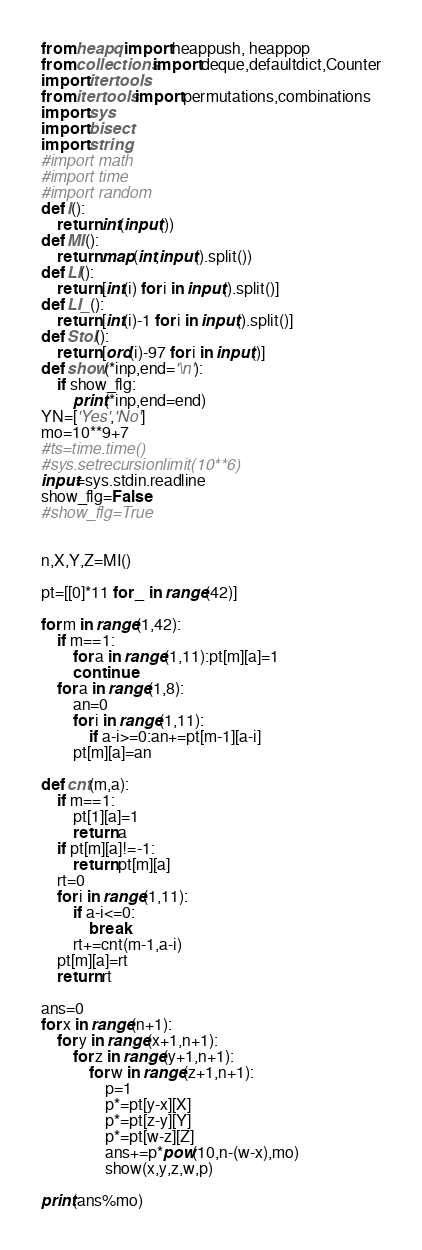<code> <loc_0><loc_0><loc_500><loc_500><_Python_>from heapq import heappush, heappop
from collections import deque,defaultdict,Counter
import itertools
from itertools import permutations,combinations
import sys
import bisect
import string
#import math
#import time
#import random
def I():
    return int(input())
def MI():
    return map(int,input().split())
def LI():
    return [int(i) for i in input().split()]
def LI_():
    return [int(i)-1 for i in input().split()]
def StoI():
    return [ord(i)-97 for i in input()]
def show(*inp,end='\n'):
    if show_flg:
        print(*inp,end=end)
YN=['Yes','No']
mo=10**9+7
#ts=time.time()
#sys.setrecursionlimit(10**6)
input=sys.stdin.readline
show_flg=False
#show_flg=True


n,X,Y,Z=MI()

pt=[[0]*11 for _ in range(42)]

for m in range(1,42):
    if m==1:
        for a in range(1,11):pt[m][a]=1
        continue
    for a in range(1,8):
        an=0
        for i in range(1,11):
            if a-i>=0:an+=pt[m-1][a-i]
        pt[m][a]=an
    
def cnt(m,a):
    if m==1:
        pt[1][a]=1
        return a
    if pt[m][a]!=-1:
        return pt[m][a]
    rt=0
    for i in range(1,11):
        if a-i<=0:
            break
        rt+=cnt(m-1,a-i)
    pt[m][a]=rt
    return rt

ans=0
for x in range(n+1):
    for y in range(x+1,n+1):
        for z in range(y+1,n+1):
            for w in range(z+1,n+1):
                p=1
                p*=pt[y-x][X]
                p*=pt[z-y][Y]
                p*=pt[w-z][Z]
                ans+=p*pow(10,n-(w-x),mo)
                show(x,y,z,w,p)

print(ans%mo)


</code> 